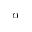Convert formula to latex. <formula><loc_0><loc_0><loc_500><loc_500>\alpha</formula> 